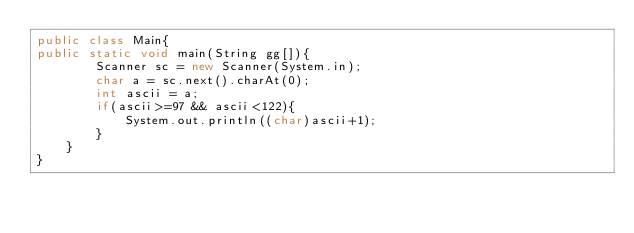Convert code to text. <code><loc_0><loc_0><loc_500><loc_500><_Java_>public class Main{
public static void main(String gg[]){
        Scanner sc = new Scanner(System.in);
        char a = sc.next().charAt(0);
        int ascii = a;
        if(ascii>=97 && ascii<122){
            System.out.println((char)ascii+1);
        }
    }
}</code> 